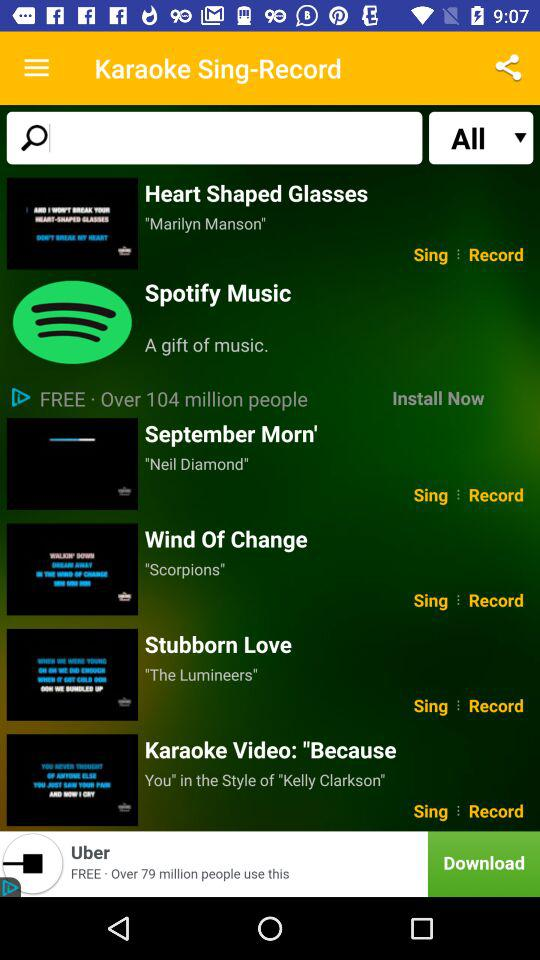How many people used the free version? The number of people who used the free version is over 104 million. 